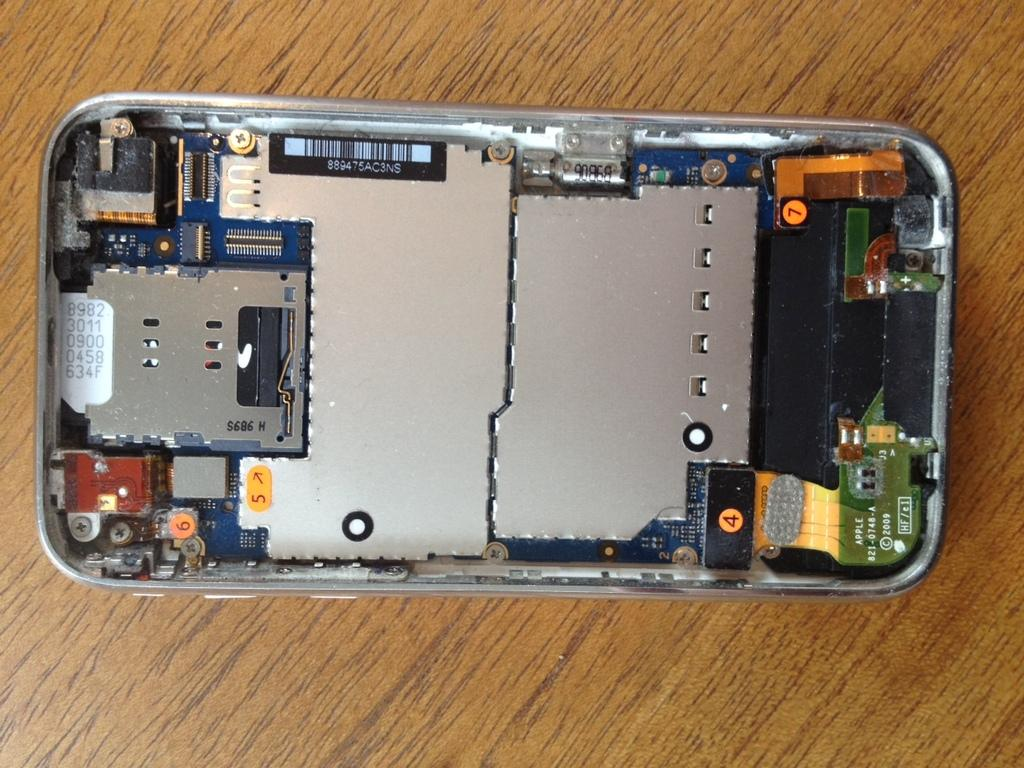<image>
Create a compact narrative representing the image presented. The bottom of a device circuit board with the numbers 8982301109000458634f. 